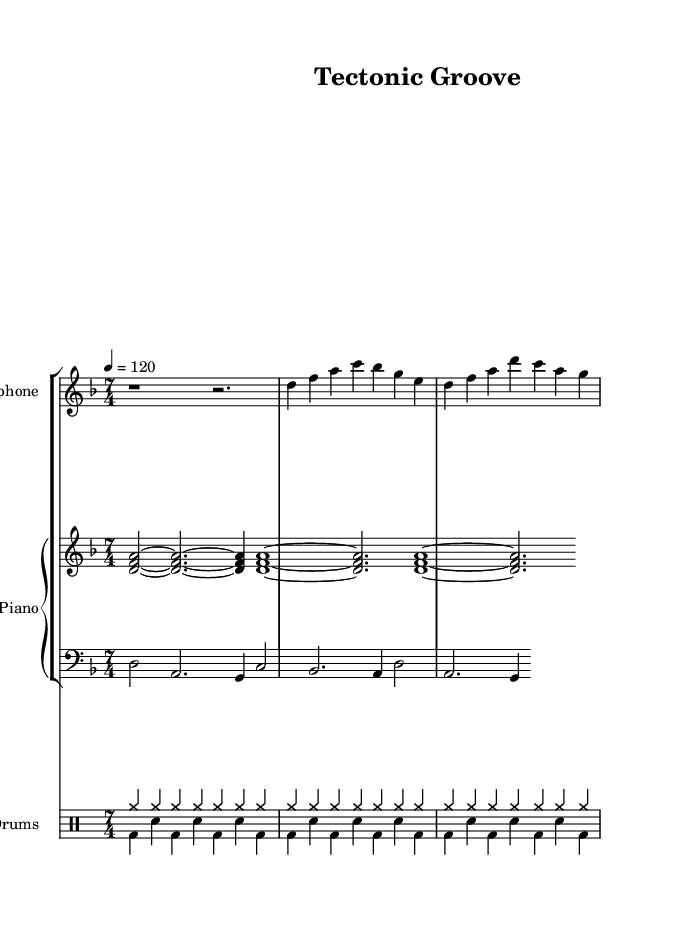What is the key signature of this music? The key signature is marked at the beginning of the piece, indicating D minor, which has one flat.
Answer: D minor What is the time signature of this music? The time signature is shown at the beginning of the piece, where 7/4 indicates there are seven beats in a measure, with the quarter note getting one beat.
Answer: 7/4 What is the tempo marking for this piece? The tempo marking is indicated as "4 = 120," which means there are 120 beats per minute, where the quarter note is the reference note.
Answer: 120 How many measures are there in the saxophone part? By counting the measures represented in the saxophone part, we find there are a total of four measures visible in the provided section.
Answer: 4 What type of jazz does this piece exemplify? The incorporation of sounds designed to mimic geological phenomena, such as volcanic eruptions and seismic activity, in a jazz context exemplifies fusion jazz.
Answer: Fusion jazz What is the instrumentation in this piece? The sheet music indicates the presence of saxophone, piano (including bass), and drums, which collectively create the musical texture of the piece.
Answer: Saxophone, piano, drums What is the first note in the piano part? Looking at the first measure of the piano part, the first note played is a D.
Answer: D 